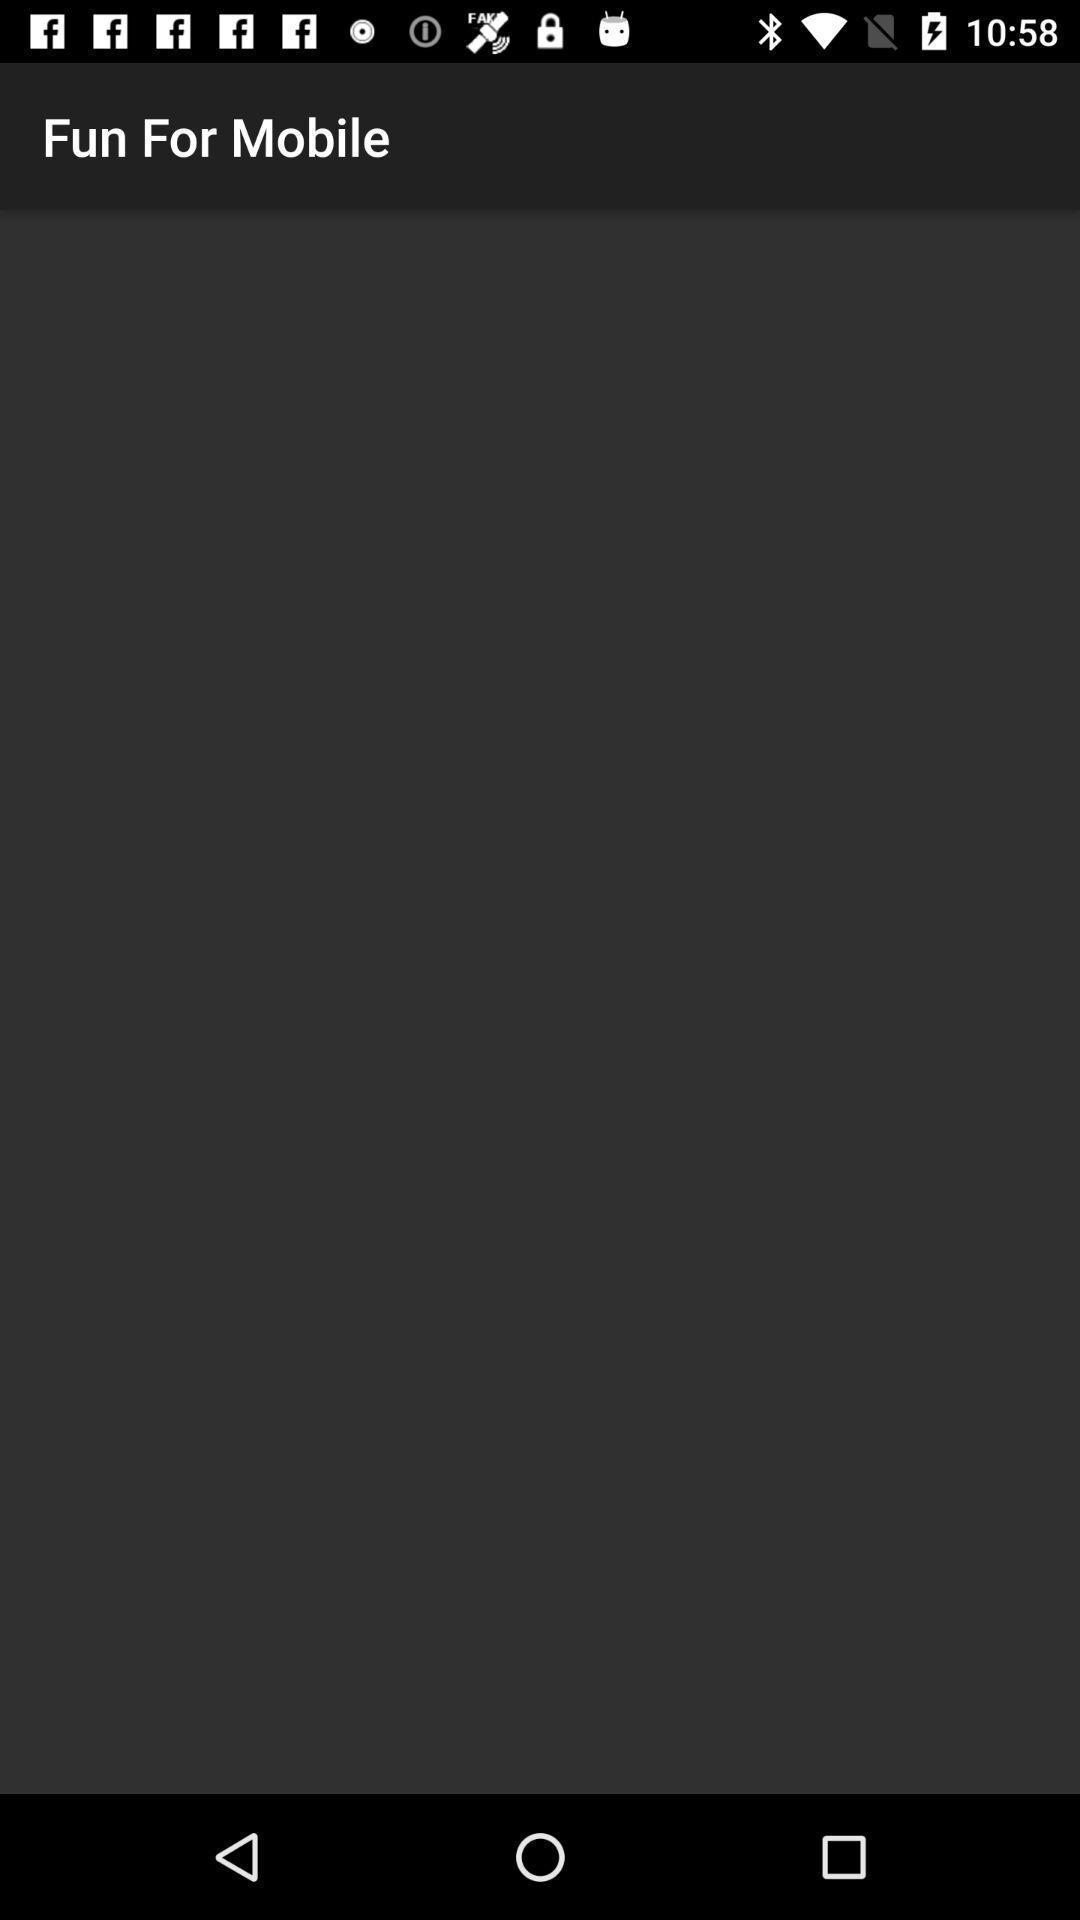Tell me about the visual elements in this screen capture. Screen shows fun for mobile blank page. 